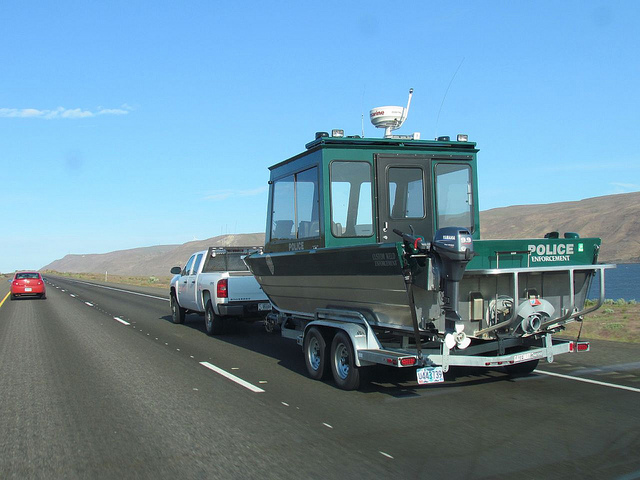Identify and read out the text in this image. POLICE POLICE ENFORCEMENT 